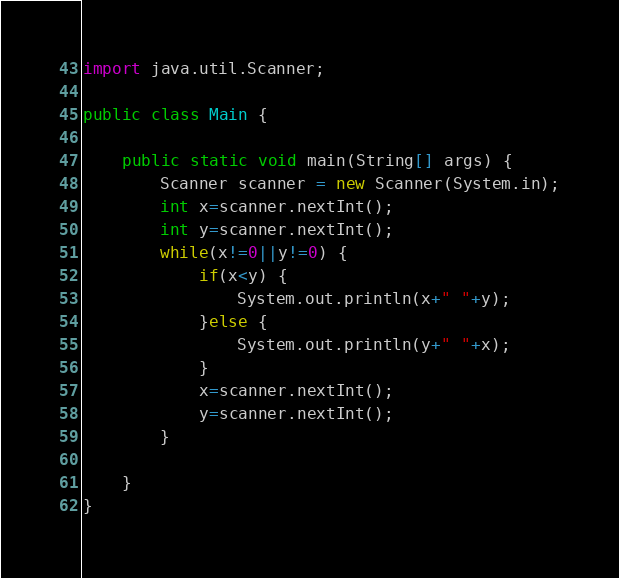<code> <loc_0><loc_0><loc_500><loc_500><_Java_>
import java.util.Scanner;

public class Main {

	public static void main(String[] args) {
		Scanner scanner = new Scanner(System.in);
		int x=scanner.nextInt();
		int y=scanner.nextInt();
		while(x!=0||y!=0) {
			if(x<y) {
				System.out.println(x+" "+y);
			}else {
				System.out.println(y+" "+x);
			}
			x=scanner.nextInt();
			y=scanner.nextInt();
		}

	}
}

</code> 